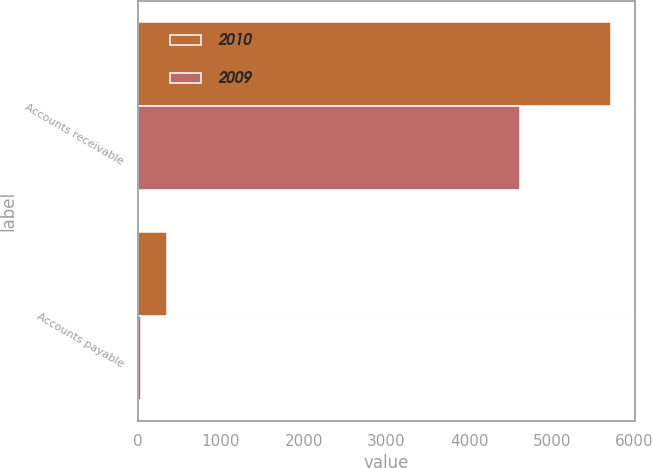Convert chart. <chart><loc_0><loc_0><loc_500><loc_500><stacked_bar_chart><ecel><fcel>Accounts receivable<fcel>Accounts payable<nl><fcel>2010<fcel>5719<fcel>354<nl><fcel>2009<fcel>4614<fcel>34<nl></chart> 